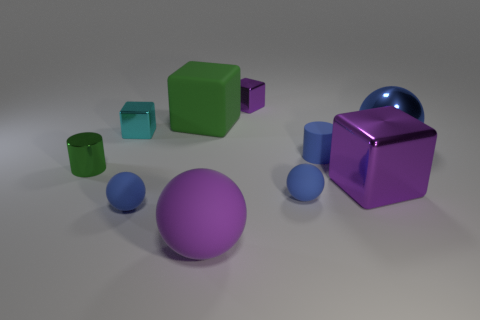Subtract all blue balls. How many were subtracted if there are1blue balls left? 2 Subtract all blue balls. How many balls are left? 1 Add 7 blue shiny objects. How many blue shiny objects exist? 8 Subtract all cyan cubes. How many cubes are left? 3 Subtract 1 purple balls. How many objects are left? 9 Subtract all cylinders. How many objects are left? 8 Subtract 1 blocks. How many blocks are left? 3 Subtract all brown cylinders. Subtract all cyan balls. How many cylinders are left? 2 Subtract all brown cylinders. How many blue balls are left? 3 Subtract all cyan blocks. Subtract all tiny brown rubber cylinders. How many objects are left? 9 